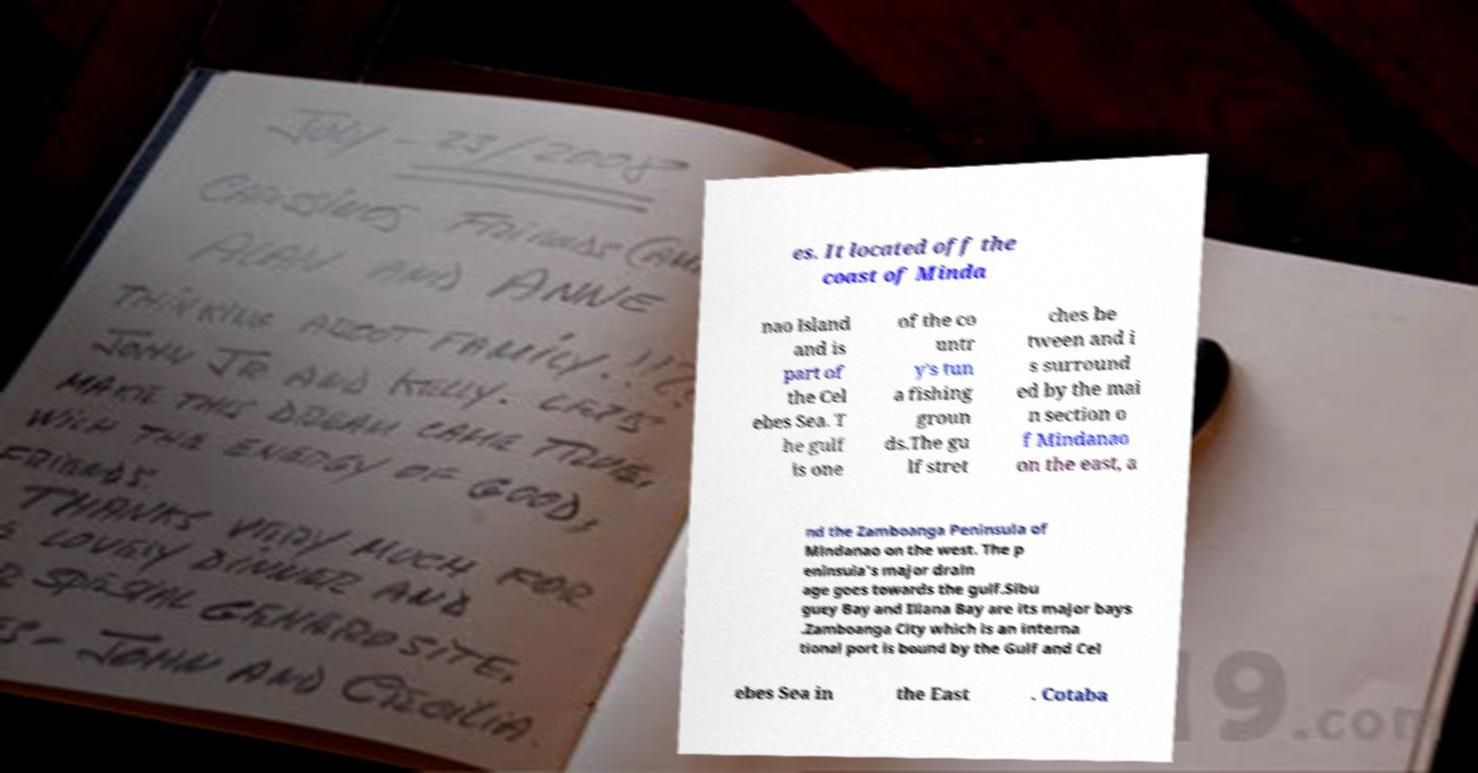Can you accurately transcribe the text from the provided image for me? es. It located off the coast of Minda nao Island and is part of the Cel ebes Sea. T he gulf is one of the co untr y's tun a fishing groun ds.The gu lf stret ches be tween and i s surround ed by the mai n section o f Mindanao on the east, a nd the Zamboanga Peninsula of Mindanao on the west. The p eninsula's major drain age goes towards the gulf.Sibu guey Bay and Illana Bay are its major bays .Zamboanga City which is an interna tional port is bound by the Gulf and Cel ebes Sea in the East . Cotaba 